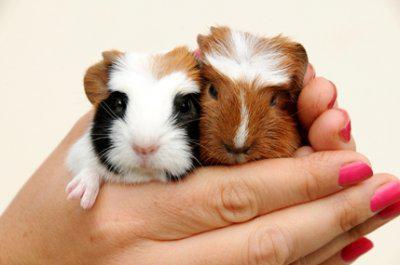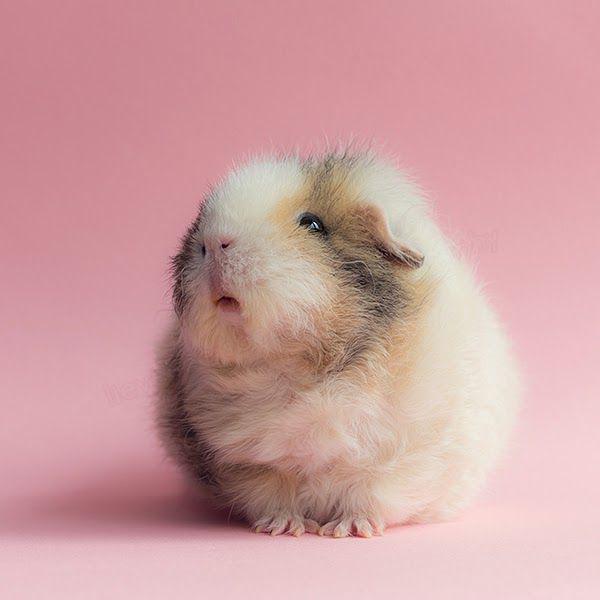The first image is the image on the left, the second image is the image on the right. Analyze the images presented: Is the assertion "At least one image contains two guinea pigs." valid? Answer yes or no. Yes. 